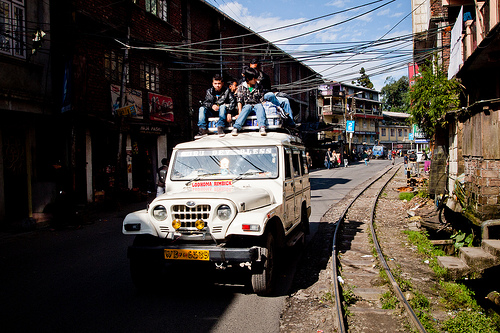<image>
Can you confirm if the white jeep is to the right of the tracks? No. The white jeep is not to the right of the tracks. The horizontal positioning shows a different relationship. 